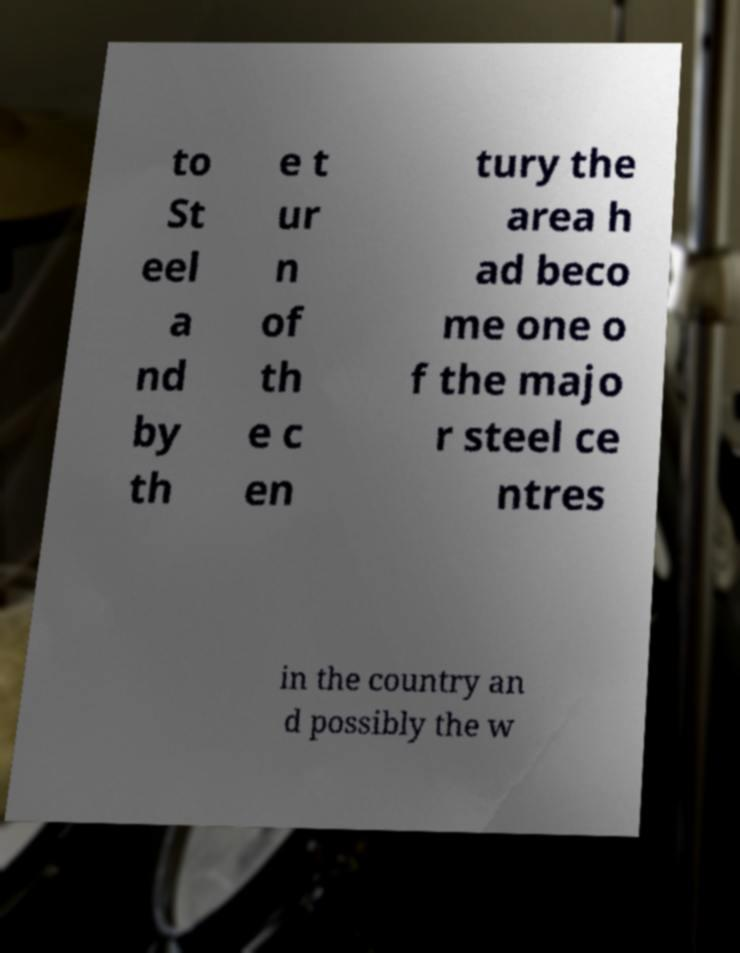I need the written content from this picture converted into text. Can you do that? to St eel a nd by th e t ur n of th e c en tury the area h ad beco me one o f the majo r steel ce ntres in the country an d possibly the w 